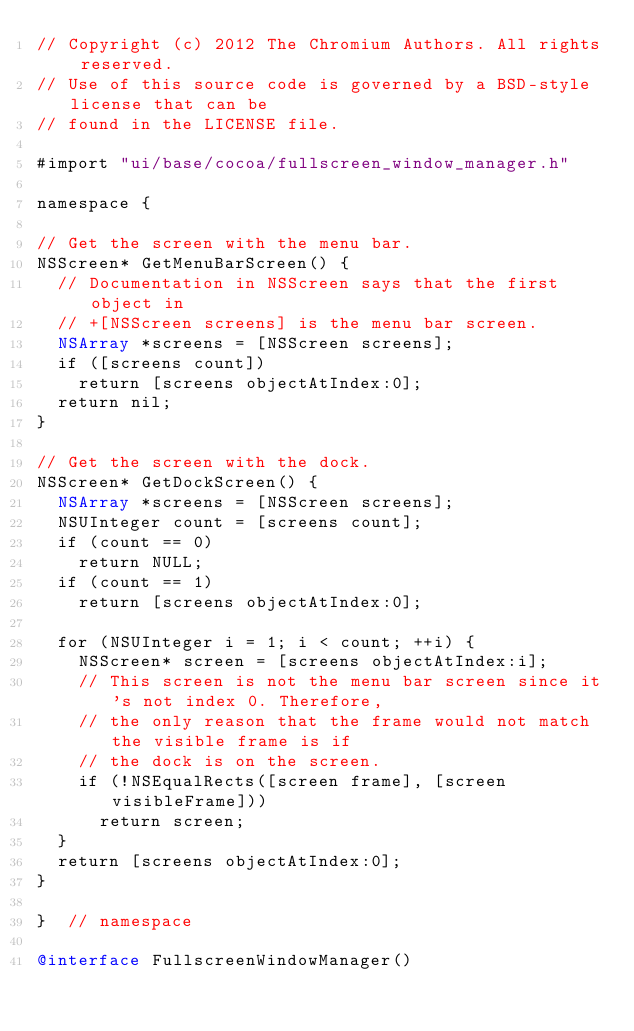<code> <loc_0><loc_0><loc_500><loc_500><_ObjectiveC_>// Copyright (c) 2012 The Chromium Authors. All rights reserved.
// Use of this source code is governed by a BSD-style license that can be
// found in the LICENSE file.

#import "ui/base/cocoa/fullscreen_window_manager.h"

namespace {

// Get the screen with the menu bar.
NSScreen* GetMenuBarScreen() {
  // Documentation in NSScreen says that the first object in
  // +[NSScreen screens] is the menu bar screen.
  NSArray *screens = [NSScreen screens];
  if ([screens count])
    return [screens objectAtIndex:0];
  return nil;
}

// Get the screen with the dock.
NSScreen* GetDockScreen() {
  NSArray *screens = [NSScreen screens];
  NSUInteger count = [screens count];
  if (count == 0)
    return NULL;
  if (count == 1)
    return [screens objectAtIndex:0];

  for (NSUInteger i = 1; i < count; ++i) {
    NSScreen* screen = [screens objectAtIndex:i];
    // This screen is not the menu bar screen since it's not index 0. Therefore,
    // the only reason that the frame would not match the visible frame is if
    // the dock is on the screen.
    if (!NSEqualRects([screen frame], [screen visibleFrame]))
      return screen;
  }
  return [screens objectAtIndex:0];
}

}  // namespace

@interface FullscreenWindowManager()</code> 